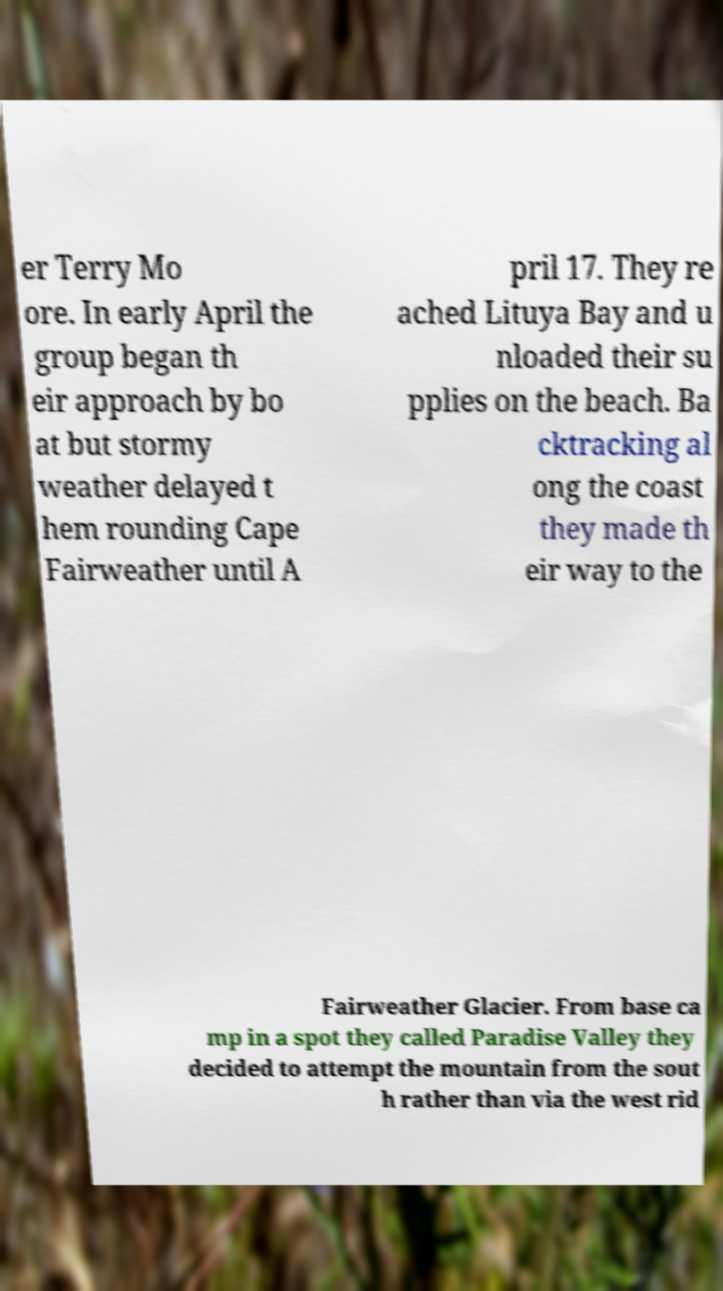Can you read and provide the text displayed in the image?This photo seems to have some interesting text. Can you extract and type it out for me? er Terry Mo ore. In early April the group began th eir approach by bo at but stormy weather delayed t hem rounding Cape Fairweather until A pril 17. They re ached Lituya Bay and u nloaded their su pplies on the beach. Ba cktracking al ong the coast they made th eir way to the Fairweather Glacier. From base ca mp in a spot they called Paradise Valley they decided to attempt the mountain from the sout h rather than via the west rid 